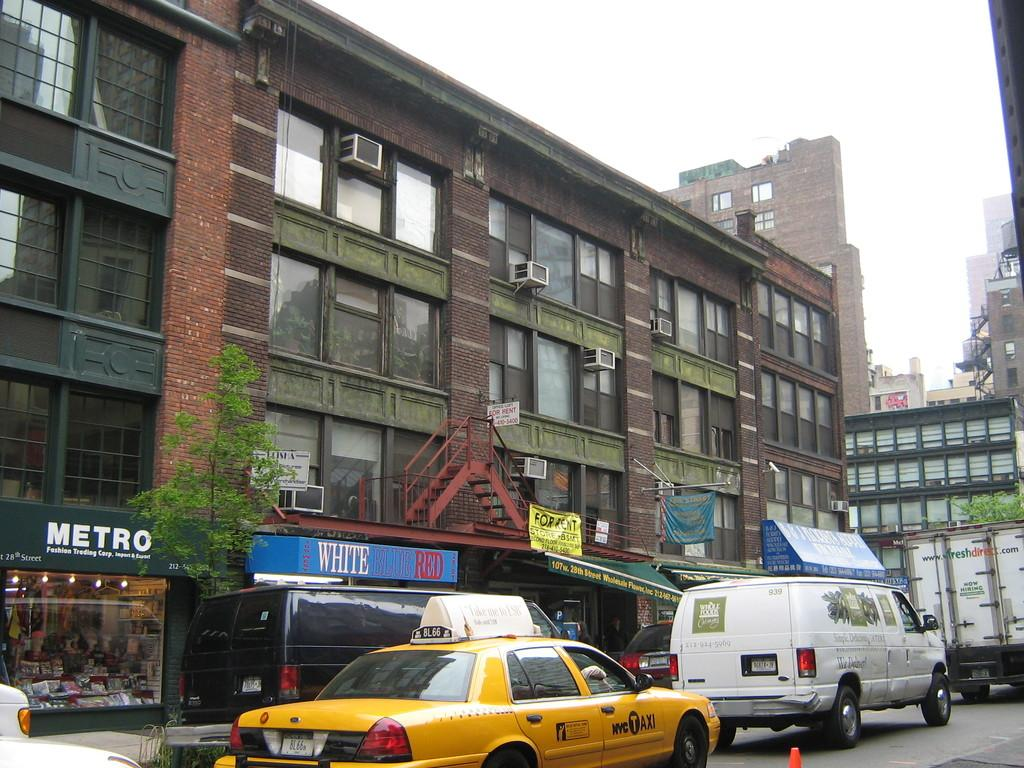<image>
Provide a brief description of the given image. A black van is parked outside an awning that says White Blue Red. 